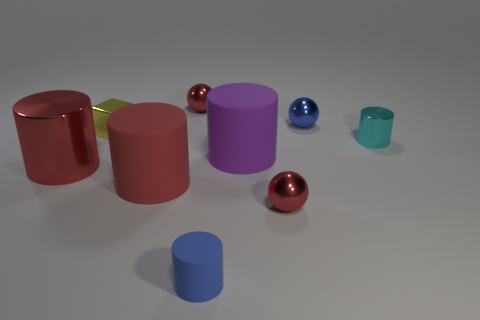Subtract all tiny blue cylinders. How many cylinders are left? 4 Subtract all purple cylinders. How many cylinders are left? 4 Subtract 2 cylinders. How many cylinders are left? 3 Subtract all yellow cylinders. Subtract all green spheres. How many cylinders are left? 5 Add 1 large red matte cylinders. How many objects exist? 10 Subtract all cylinders. How many objects are left? 4 Add 5 small yellow objects. How many small yellow objects are left? 6 Add 1 blue metallic things. How many blue metallic things exist? 2 Subtract 0 purple cubes. How many objects are left? 9 Subtract all yellow metal blocks. Subtract all large brown rubber spheres. How many objects are left? 8 